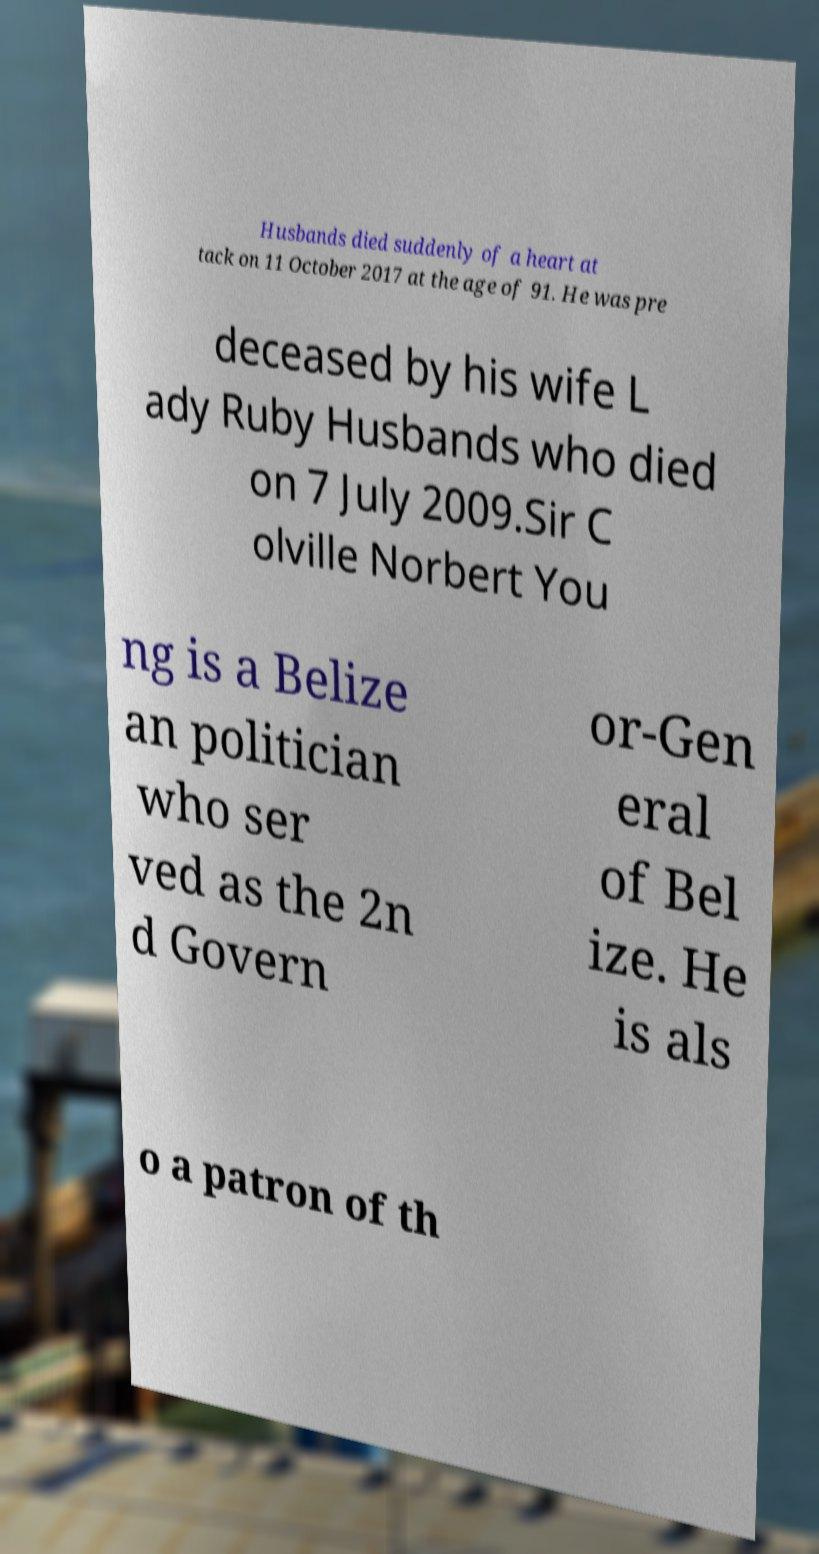What messages or text are displayed in this image? I need them in a readable, typed format. Husbands died suddenly of a heart at tack on 11 October 2017 at the age of 91. He was pre deceased by his wife L ady Ruby Husbands who died on 7 July 2009.Sir C olville Norbert You ng is a Belize an politician who ser ved as the 2n d Govern or-Gen eral of Bel ize. He is als o a patron of th 